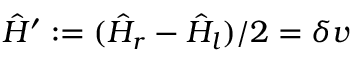Convert formula to latex. <formula><loc_0><loc_0><loc_500><loc_500>\hat { H } ^ { \prime } \colon = ( \hat { H } _ { r } - \hat { H } _ { l } ) / 2 = \delta v</formula> 